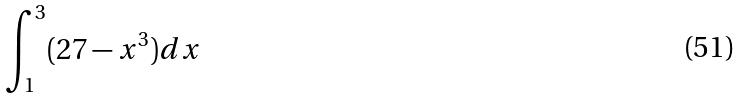Convert formula to latex. <formula><loc_0><loc_0><loc_500><loc_500>\int _ { 1 } ^ { 3 } ( 2 7 - x ^ { 3 } ) d x</formula> 